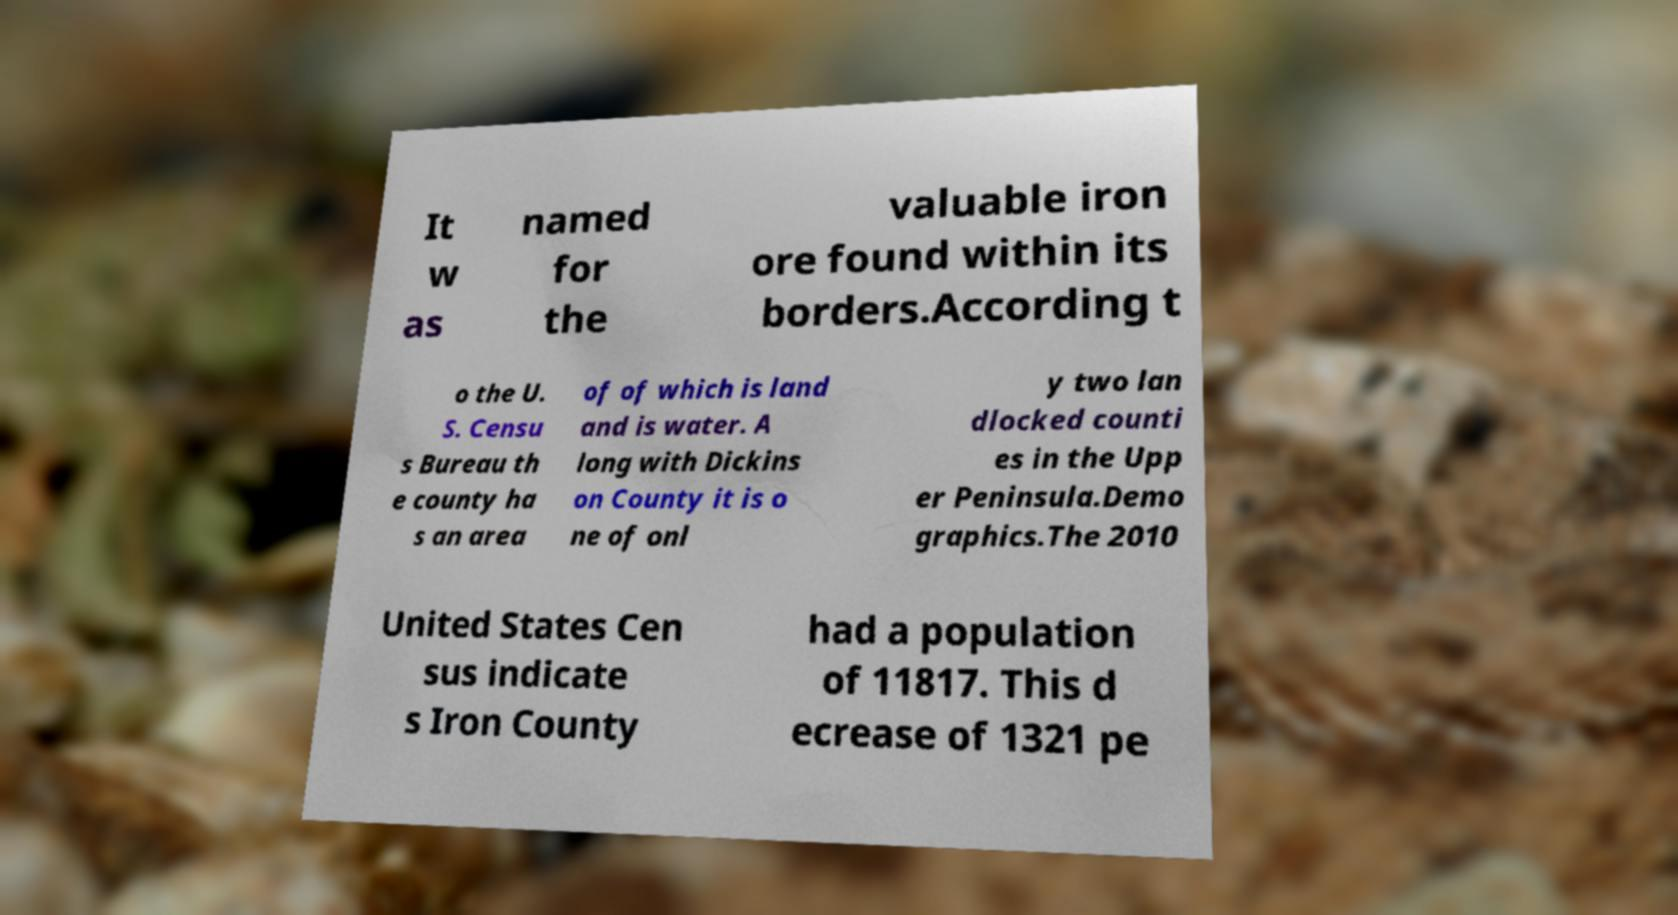Please read and relay the text visible in this image. What does it say? It w as named for the valuable iron ore found within its borders.According t o the U. S. Censu s Bureau th e county ha s an area of of which is land and is water. A long with Dickins on County it is o ne of onl y two lan dlocked counti es in the Upp er Peninsula.Demo graphics.The 2010 United States Cen sus indicate s Iron County had a population of 11817. This d ecrease of 1321 pe 